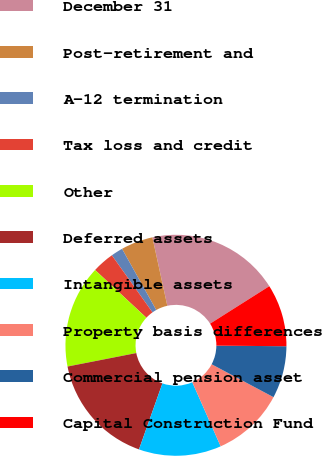<chart> <loc_0><loc_0><loc_500><loc_500><pie_chart><fcel>December 31<fcel>Post-retirement and<fcel>A-12 termination<fcel>Tax loss and credit<fcel>Other<fcel>Deferred assets<fcel>Intangible assets<fcel>Property basis differences<fcel>Commercial pension asset<fcel>Capital Construction Fund<nl><fcel>19.44%<fcel>4.69%<fcel>1.74%<fcel>3.22%<fcel>15.01%<fcel>16.49%<fcel>12.06%<fcel>10.59%<fcel>7.64%<fcel>9.12%<nl></chart> 